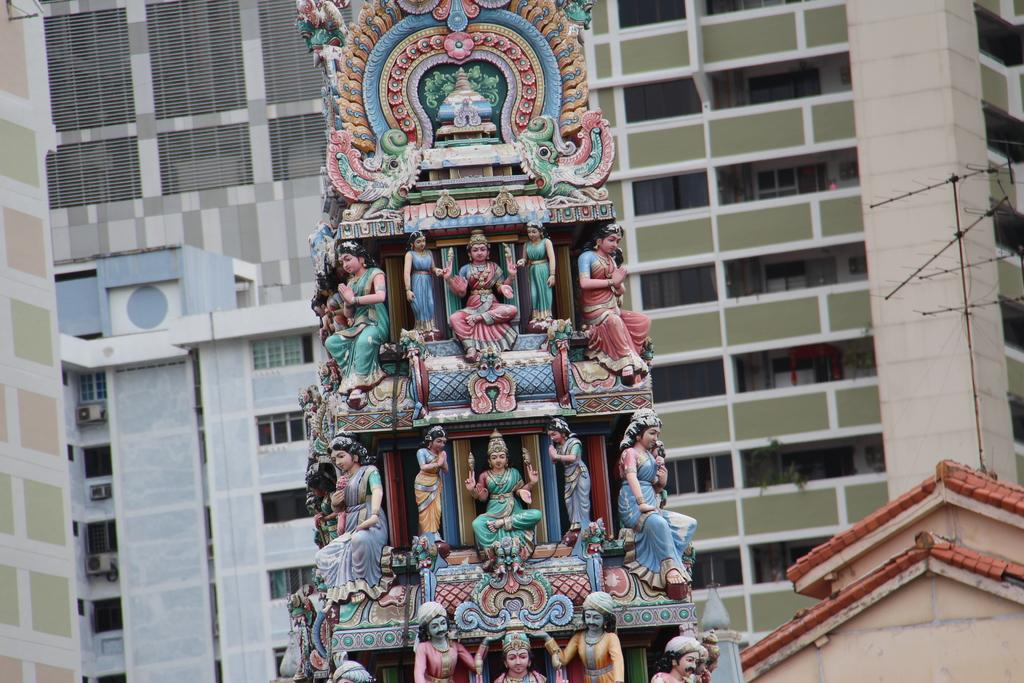What type of structures can be seen in the image? There are statues and a building with windows in the image. What additional feature is present in the image? There is an antenna in the image. Can you describe the building in the image? The building has windows, but no specific details about its size, shape, or color are provided. What else can be seen in the image that is not specified? There are unspecified objects in the image. Are there any cobwebs visible on the statues in the image? There is no mention of cobwebs in the provided facts, so we cannot determine their presence or absence in the image. 